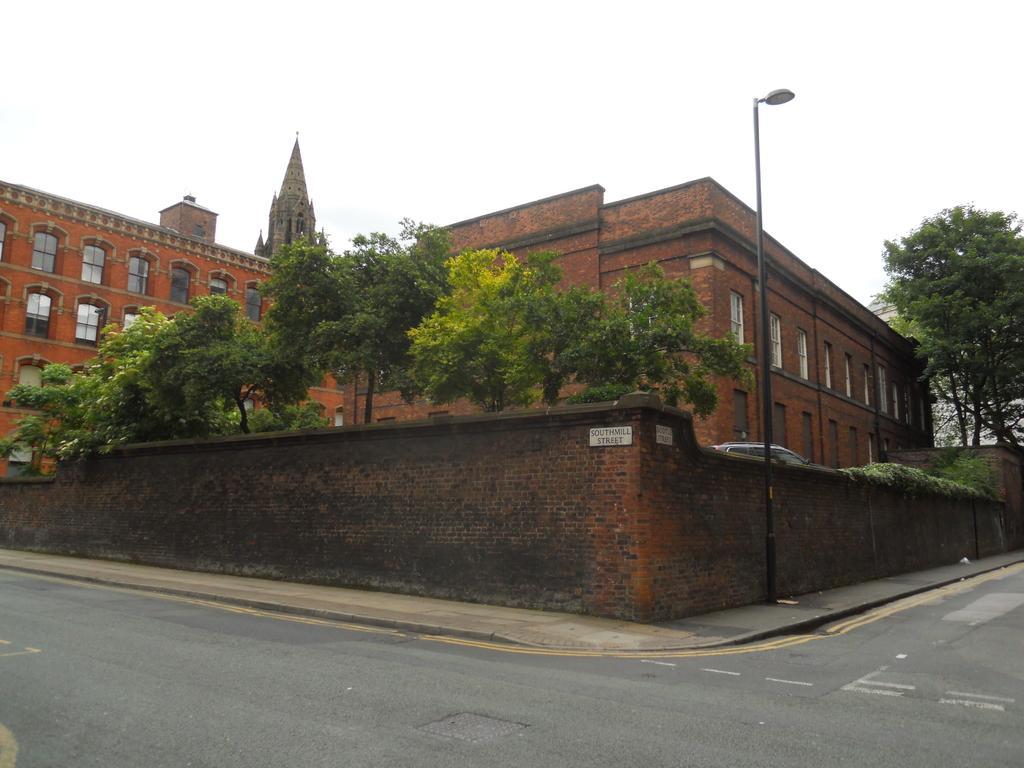Please provide a concise description of this image. In this image there are buildings and trees. At the bottom there is a road and a wall. We can see a pole. There is a car. In the background there is sky. 